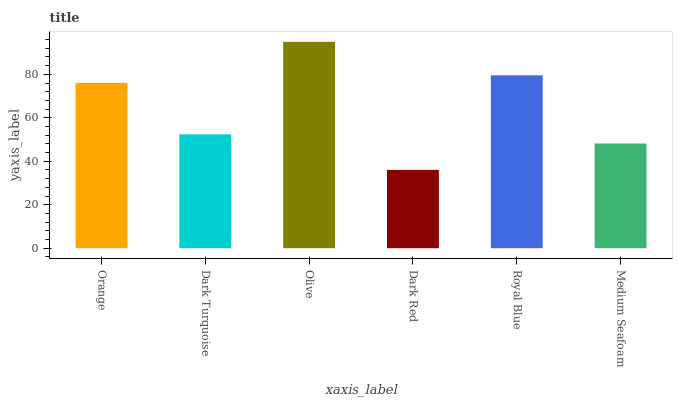Is Dark Red the minimum?
Answer yes or no. Yes. Is Olive the maximum?
Answer yes or no. Yes. Is Dark Turquoise the minimum?
Answer yes or no. No. Is Dark Turquoise the maximum?
Answer yes or no. No. Is Orange greater than Dark Turquoise?
Answer yes or no. Yes. Is Dark Turquoise less than Orange?
Answer yes or no. Yes. Is Dark Turquoise greater than Orange?
Answer yes or no. No. Is Orange less than Dark Turquoise?
Answer yes or no. No. Is Orange the high median?
Answer yes or no. Yes. Is Dark Turquoise the low median?
Answer yes or no. Yes. Is Olive the high median?
Answer yes or no. No. Is Royal Blue the low median?
Answer yes or no. No. 